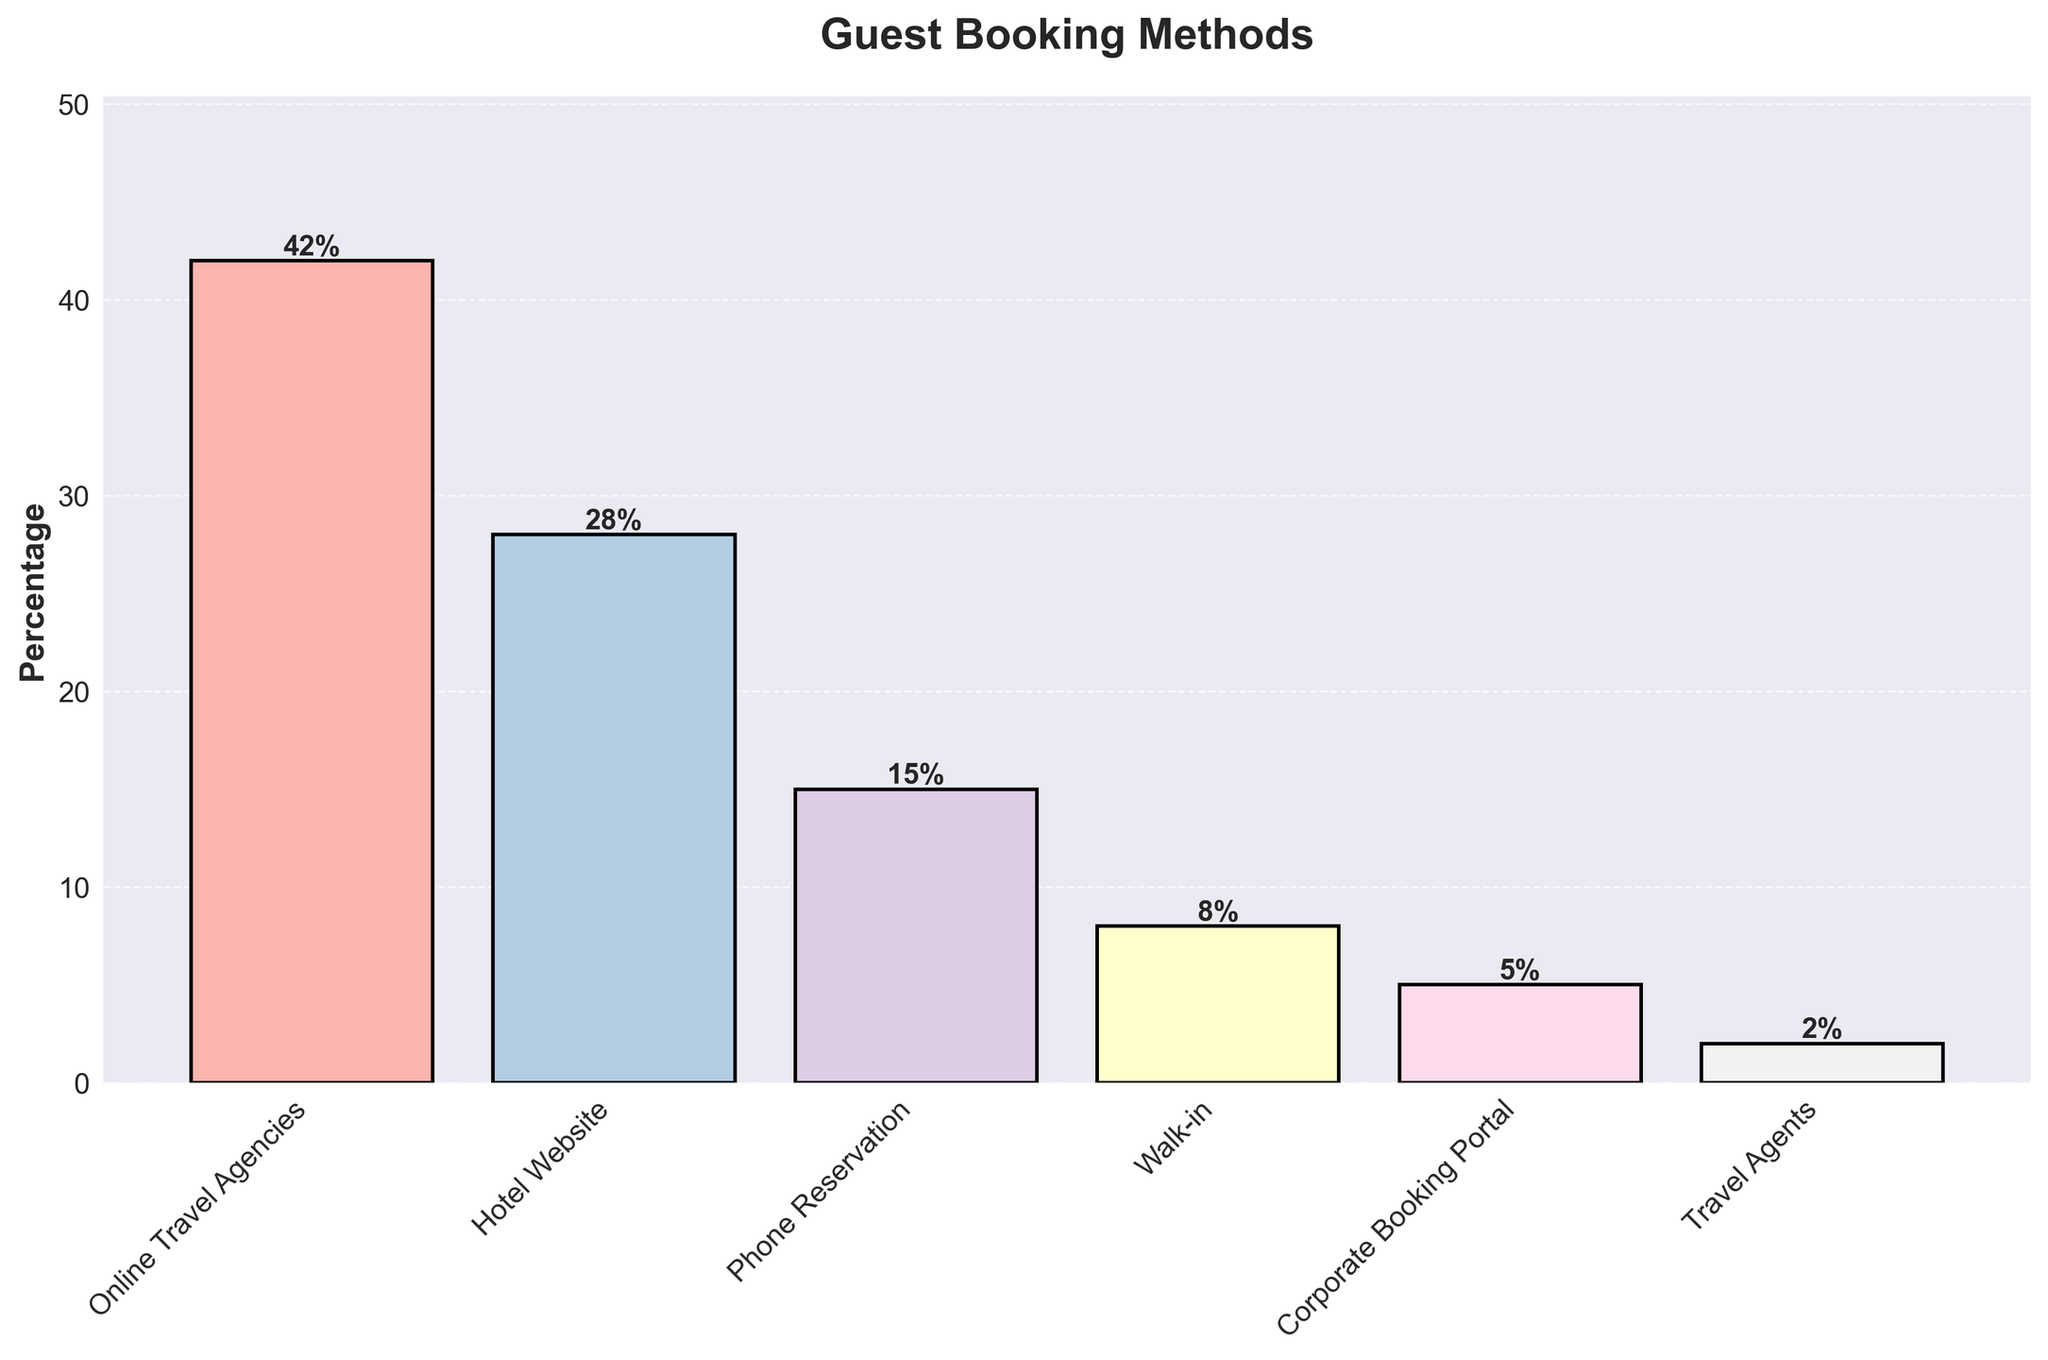Which booking method is the most popular among guests? The bar representing 'Online Travel Agencies' is the highest, indicating it has the highest percentage.
Answer: Online Travel Agencies What is the combined percentage of guests using phone reservations and walk-ins? Add the percentages for 'Phone Reservation' (15%) and 'Walk-in' (8%): 15 + 8 = 23%
Answer: 23% How much higher is the percentage of guests booking through hotel websites compared to corporate booking portals? Subtract the percentage of 'Corporate Booking Portal' (5%) from 'Hotel Website' (28%): 28 - 5 = 23%
Answer: 23% Which booking method has the lowest percentage of guests? The bar for 'Travel Agents' is the shortest, indicating it has the lowest percentage.
Answer: Travel Agents Compare the percentage of guests using travel agents to those using corporate booking portals. Which is higher? The bar for 'Corporate Booking Portal' (5%) is higher than the bar for 'Travel Agents' (2%).
Answer: Corporate Booking Portal What is the average percentage of guests using all the booking methods listed? Sum all percentages (42 + 28 + 15 + 8 + 5 + 2) = 100, then divide by the number of methods (6): 100 / 6 ≈ 16.67%
Answer: 16.67% By how much does the use of online travel agencies exceed phone reservations? Subtract the percentage for 'Phone Reservation' (15%) from 'Online Travel Agencies' (42%): 42 - 15 = 27%
Answer: 27% What is the percentage difference between guests using walk-ins and those using the hotel's website? Subtract the percentage for 'Walk-in' (8%) from 'Hotel Website' (28%): 28 - 8 = 20%
Answer: 20% Which booking methods have a percentage of guests above 20%? The bars for 'Online Travel Agencies' (42%) and 'Hotel Website' (28%) are above 20%.
Answer: Online Travel Agencies, Hotel Website Is the percentage of guests using phone reservations more than one-third of those using online travel agencies? One-third of 'Online Travel Agencies' (42%) is 42 / 3 = 14%. 'Phone Reservation' is 15%, which is more than 14%.
Answer: Yes 